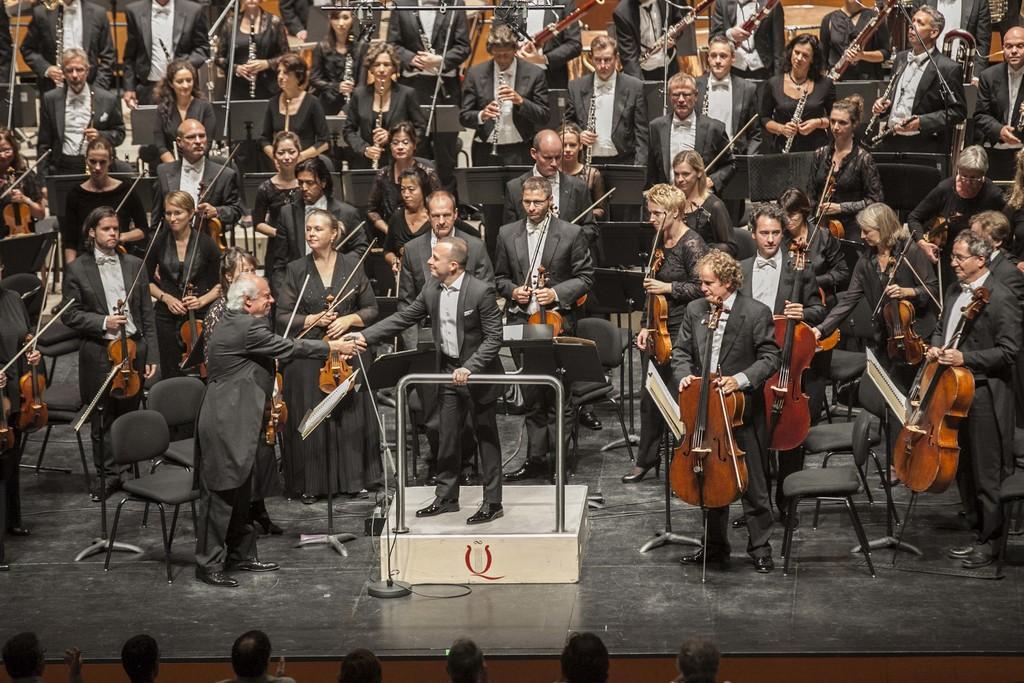Please provide a concise description of this image. In this image I can see a group of people are standing and playing musical instruments. I can also see a man is standing on a subject and shaking hand with other person. 